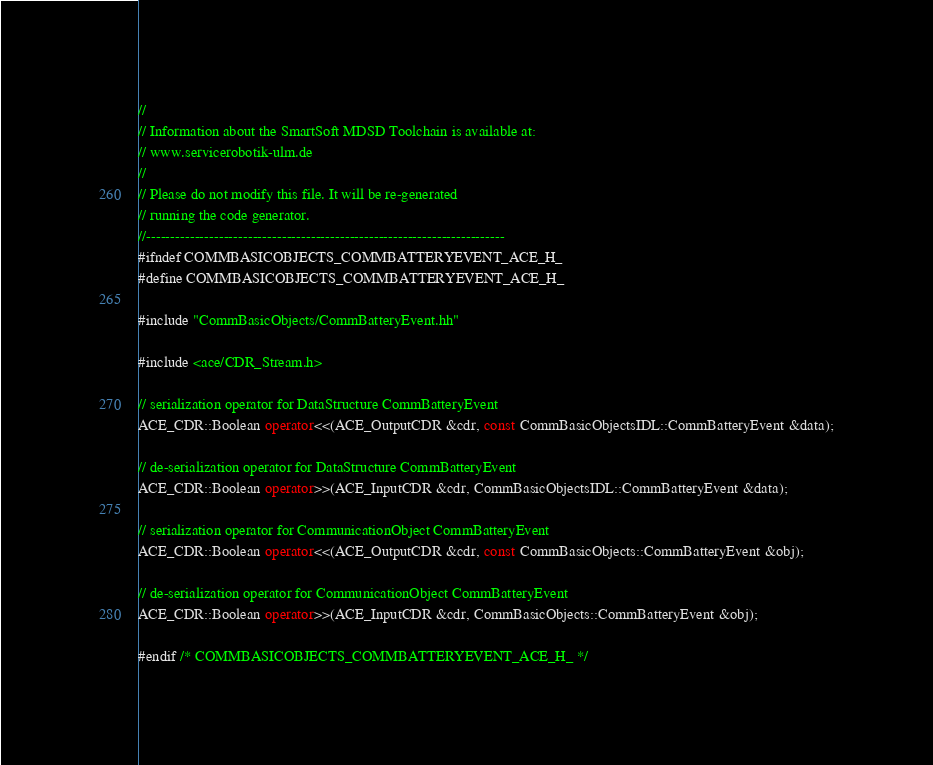Convert code to text. <code><loc_0><loc_0><loc_500><loc_500><_C++_>//
// Information about the SmartSoft MDSD Toolchain is available at:
// www.servicerobotik-ulm.de
//
// Please do not modify this file. It will be re-generated
// running the code generator.
//--------------------------------------------------------------------------
#ifndef COMMBASICOBJECTS_COMMBATTERYEVENT_ACE_H_
#define COMMBASICOBJECTS_COMMBATTERYEVENT_ACE_H_

#include "CommBasicObjects/CommBatteryEvent.hh"

#include <ace/CDR_Stream.h>

// serialization operator for DataStructure CommBatteryEvent
ACE_CDR::Boolean operator<<(ACE_OutputCDR &cdr, const CommBasicObjectsIDL::CommBatteryEvent &data);

// de-serialization operator for DataStructure CommBatteryEvent
ACE_CDR::Boolean operator>>(ACE_InputCDR &cdr, CommBasicObjectsIDL::CommBatteryEvent &data);

// serialization operator for CommunicationObject CommBatteryEvent
ACE_CDR::Boolean operator<<(ACE_OutputCDR &cdr, const CommBasicObjects::CommBatteryEvent &obj);

// de-serialization operator for CommunicationObject CommBatteryEvent
ACE_CDR::Boolean operator>>(ACE_InputCDR &cdr, CommBasicObjects::CommBatteryEvent &obj);

#endif /* COMMBASICOBJECTS_COMMBATTERYEVENT_ACE_H_ */
</code> 